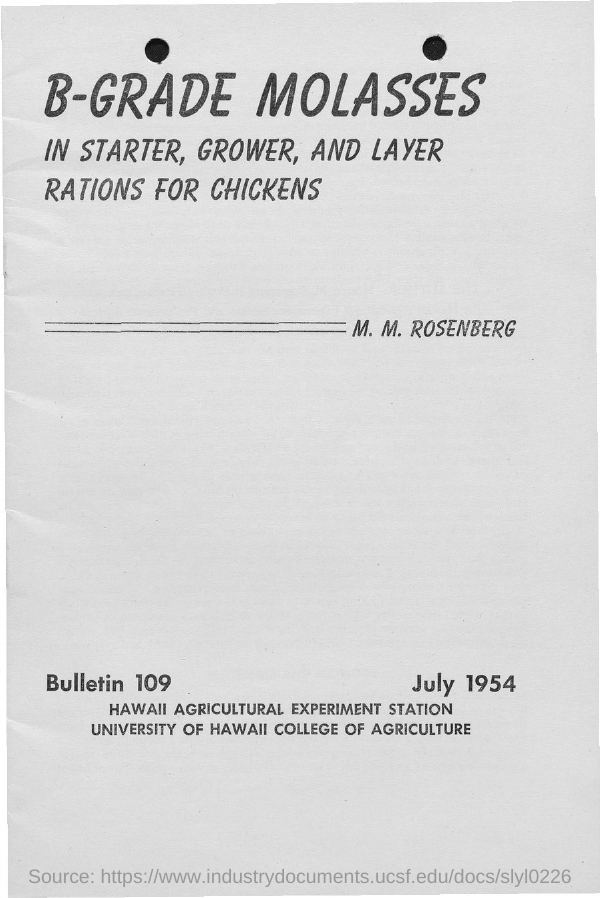What is the first title in the document?
Give a very brief answer. B-Grade Molasses. What is the date mentioned in the document?
Your answer should be compact. July 1954. What is the bulletin number?
Offer a terse response. 109. 